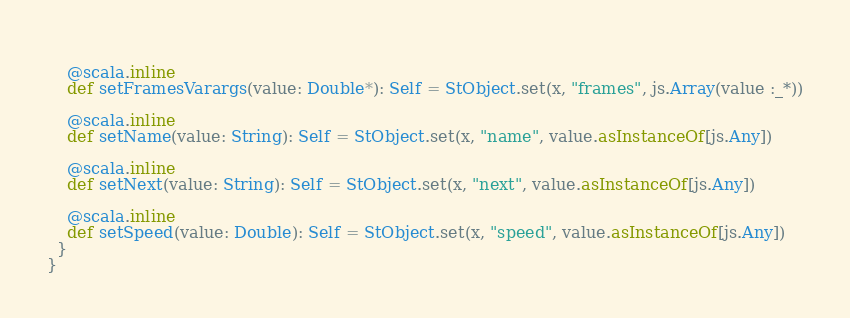<code> <loc_0><loc_0><loc_500><loc_500><_Scala_>    
    @scala.inline
    def setFramesVarargs(value: Double*): Self = StObject.set(x, "frames", js.Array(value :_*))
    
    @scala.inline
    def setName(value: String): Self = StObject.set(x, "name", value.asInstanceOf[js.Any])
    
    @scala.inline
    def setNext(value: String): Self = StObject.set(x, "next", value.asInstanceOf[js.Any])
    
    @scala.inline
    def setSpeed(value: Double): Self = StObject.set(x, "speed", value.asInstanceOf[js.Any])
  }
}
</code> 